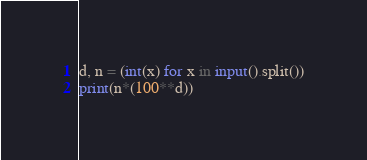Convert code to text. <code><loc_0><loc_0><loc_500><loc_500><_Python_>d, n = (int(x) for x in input().split())
print(n*(100**d))</code> 